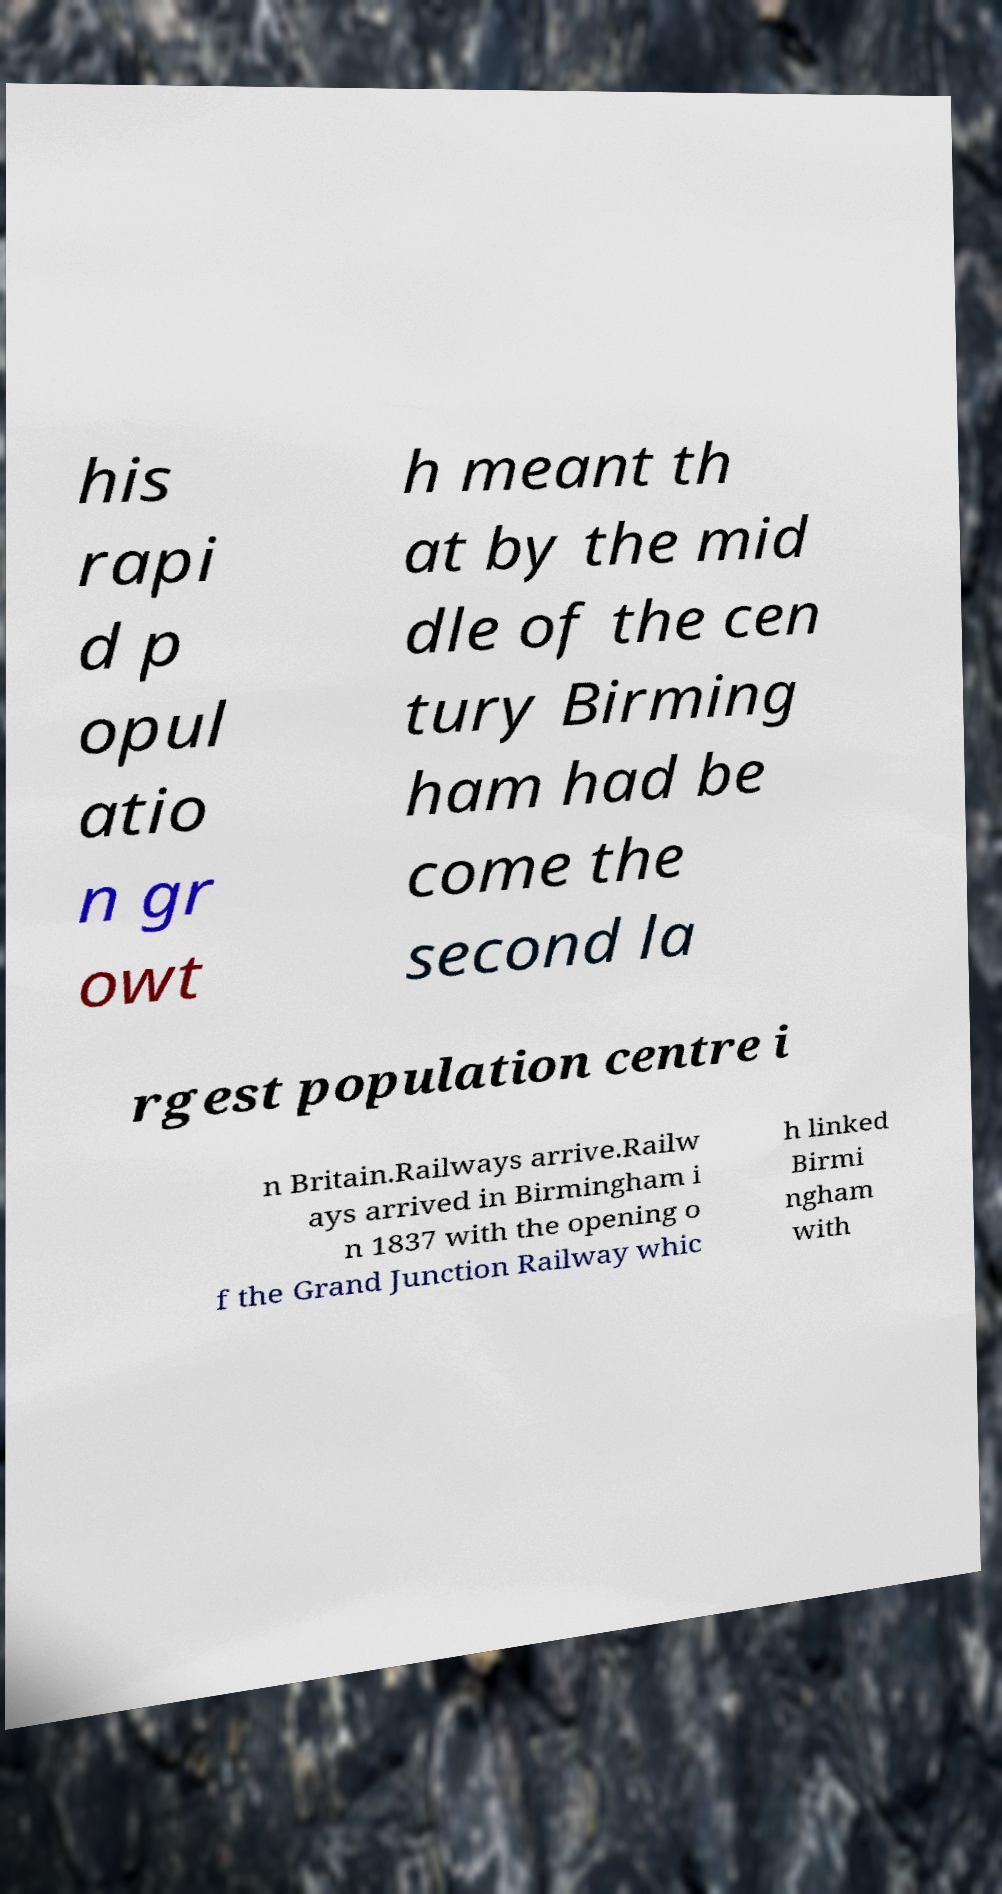For documentation purposes, I need the text within this image transcribed. Could you provide that? his rapi d p opul atio n gr owt h meant th at by the mid dle of the cen tury Birming ham had be come the second la rgest population centre i n Britain.Railways arrive.Railw ays arrived in Birmingham i n 1837 with the opening o f the Grand Junction Railway whic h linked Birmi ngham with 